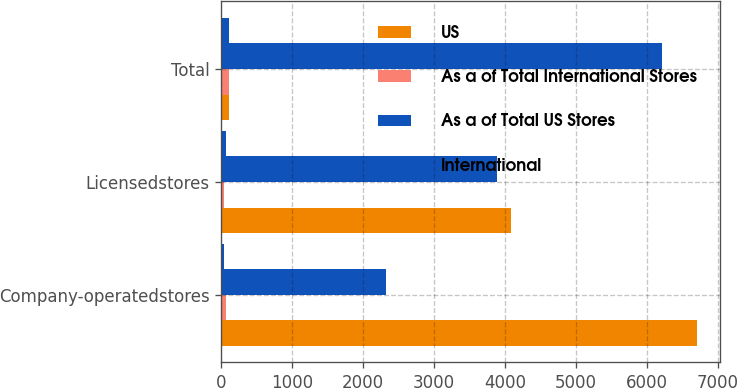Convert chart. <chart><loc_0><loc_0><loc_500><loc_500><stacked_bar_chart><ecel><fcel>Company-operatedstores<fcel>Licensedstores<fcel>Total<nl><fcel>US<fcel>6705<fcel>4082<fcel>100<nl><fcel>As a of Total International Stores<fcel>62<fcel>38<fcel>100<nl><fcel>As a of Total US Stores<fcel>2326<fcel>3890<fcel>6216<nl><fcel>International<fcel>37<fcel>63<fcel>100<nl></chart> 